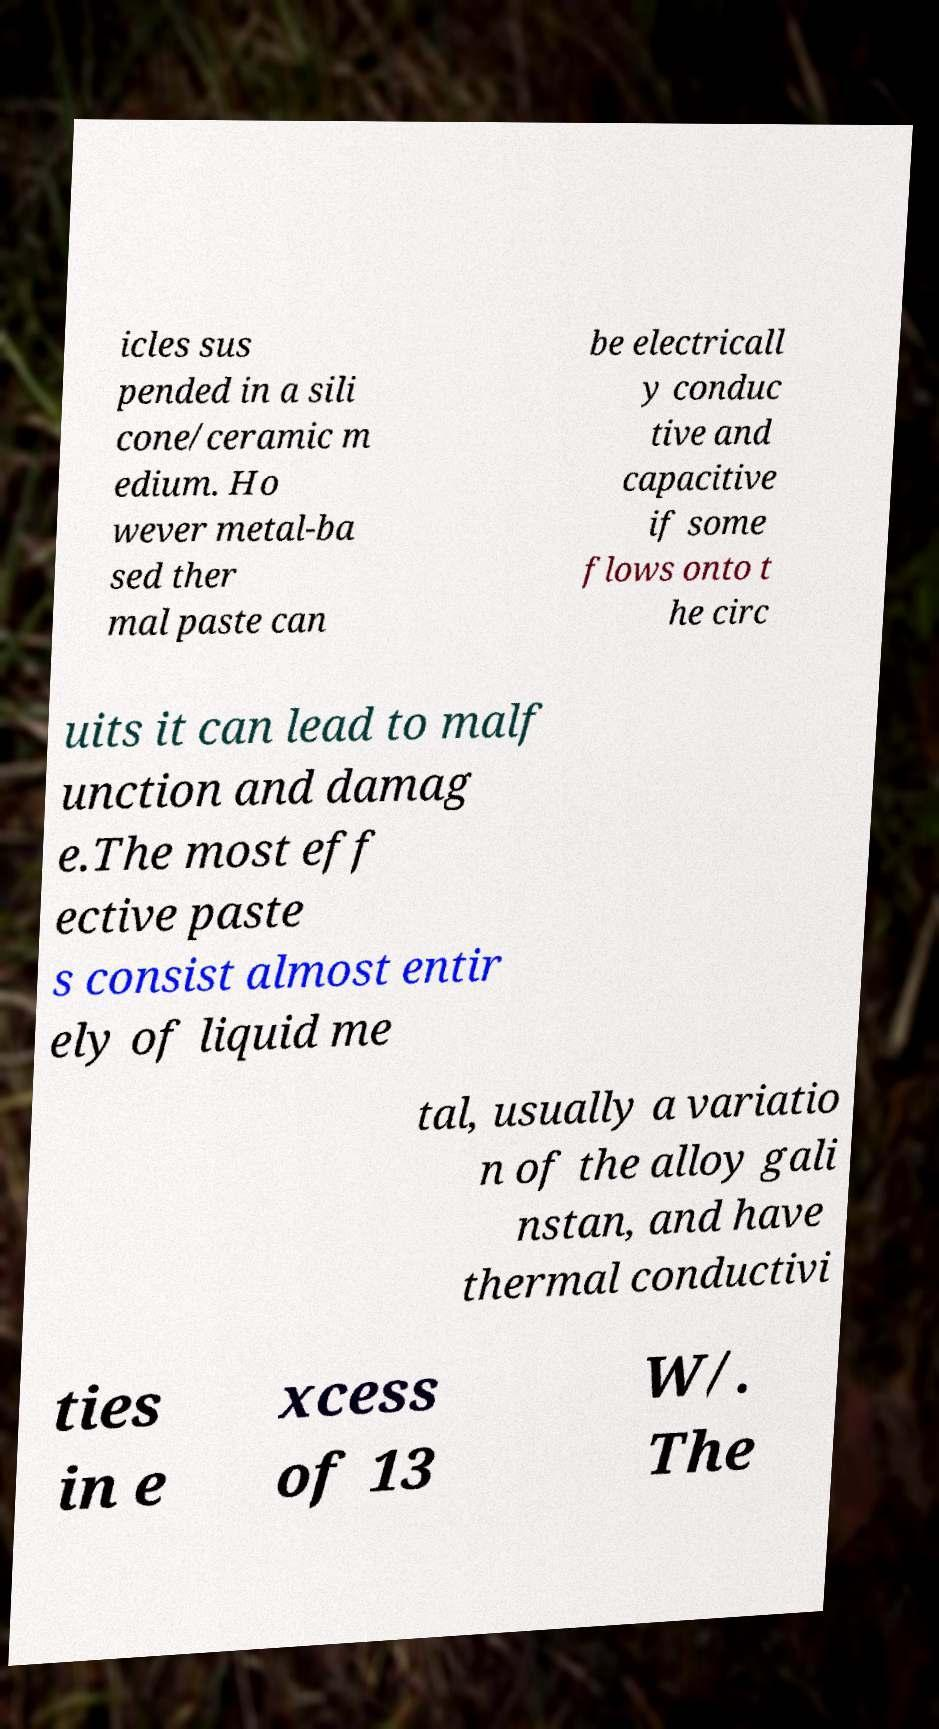For documentation purposes, I need the text within this image transcribed. Could you provide that? icles sus pended in a sili cone/ceramic m edium. Ho wever metal-ba sed ther mal paste can be electricall y conduc tive and capacitive if some flows onto t he circ uits it can lead to malf unction and damag e.The most eff ective paste s consist almost entir ely of liquid me tal, usually a variatio n of the alloy gali nstan, and have thermal conductivi ties in e xcess of 13 W/. The 